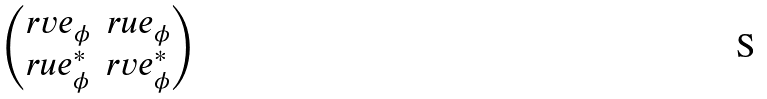Convert formula to latex. <formula><loc_0><loc_0><loc_500><loc_500>\begin{pmatrix} r v e _ { \phi } & r u e _ { \phi } \\ r u e ^ { \ast } _ { \phi } & r v e ^ { \ast } _ { \phi } \end{pmatrix}</formula> 